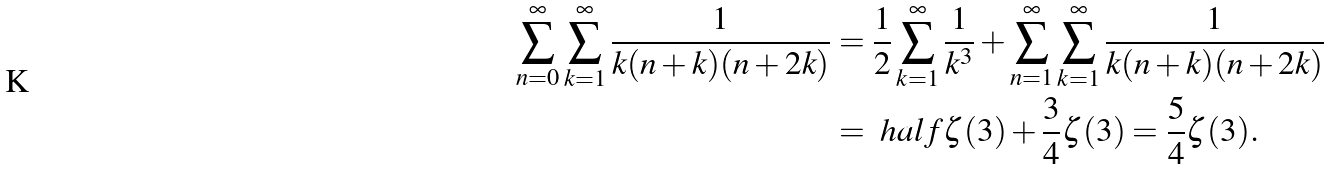Convert formula to latex. <formula><loc_0><loc_0><loc_500><loc_500>\sum _ { n = 0 } ^ { \infty } \sum _ { k = 1 } ^ { \infty } \frac { 1 } { k ( n + k ) ( n + 2 k ) } & = \frac { 1 } { 2 } \sum _ { k = 1 } ^ { \infty } \frac { 1 } { k ^ { 3 } } + \sum _ { n = 1 } ^ { \infty } \sum _ { k = 1 } ^ { \infty } \frac { 1 } { k ( n + k ) ( n + 2 k ) } \\ & = \ h a l f \zeta ( 3 ) + \frac { 3 } { 4 } \zeta ( 3 ) = \frac { 5 } { 4 } \zeta ( 3 ) .</formula> 